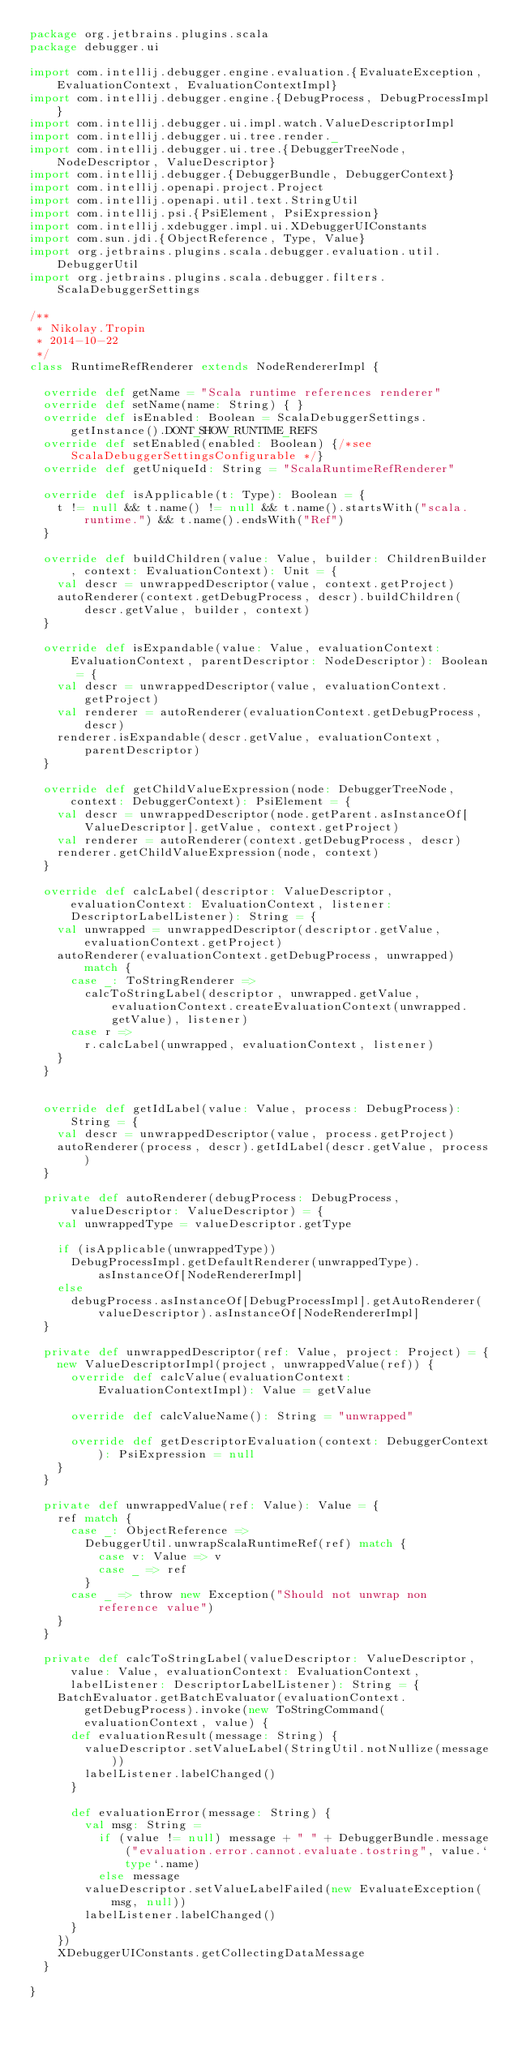<code> <loc_0><loc_0><loc_500><loc_500><_Scala_>package org.jetbrains.plugins.scala
package debugger.ui

import com.intellij.debugger.engine.evaluation.{EvaluateException, EvaluationContext, EvaluationContextImpl}
import com.intellij.debugger.engine.{DebugProcess, DebugProcessImpl}
import com.intellij.debugger.ui.impl.watch.ValueDescriptorImpl
import com.intellij.debugger.ui.tree.render._
import com.intellij.debugger.ui.tree.{DebuggerTreeNode, NodeDescriptor, ValueDescriptor}
import com.intellij.debugger.{DebuggerBundle, DebuggerContext}
import com.intellij.openapi.project.Project
import com.intellij.openapi.util.text.StringUtil
import com.intellij.psi.{PsiElement, PsiExpression}
import com.intellij.xdebugger.impl.ui.XDebuggerUIConstants
import com.sun.jdi.{ObjectReference, Type, Value}
import org.jetbrains.plugins.scala.debugger.evaluation.util.DebuggerUtil
import org.jetbrains.plugins.scala.debugger.filters.ScalaDebuggerSettings

/**
 * Nikolay.Tropin
 * 2014-10-22
 */
class RuntimeRefRenderer extends NodeRendererImpl {

  override def getName = "Scala runtime references renderer"
  override def setName(name: String) { }
  override def isEnabled: Boolean = ScalaDebuggerSettings.getInstance().DONT_SHOW_RUNTIME_REFS
  override def setEnabled(enabled: Boolean) {/*see ScalaDebuggerSettingsConfigurable */}
  override def getUniqueId: String = "ScalaRuntimeRefRenderer"

  override def isApplicable(t: Type): Boolean = {
    t != null && t.name() != null && t.name().startsWith("scala.runtime.") && t.name().endsWith("Ref")
  }
  
  override def buildChildren(value: Value, builder: ChildrenBuilder, context: EvaluationContext): Unit = {
    val descr = unwrappedDescriptor(value, context.getProject)
    autoRenderer(context.getDebugProcess, descr).buildChildren(descr.getValue, builder, context)
  }

  override def isExpandable(value: Value, evaluationContext: EvaluationContext, parentDescriptor: NodeDescriptor): Boolean = {
    val descr = unwrappedDescriptor(value, evaluationContext.getProject)
    val renderer = autoRenderer(evaluationContext.getDebugProcess, descr)
    renderer.isExpandable(descr.getValue, evaluationContext, parentDescriptor)
  }

  override def getChildValueExpression(node: DebuggerTreeNode, context: DebuggerContext): PsiElement = {
    val descr = unwrappedDescriptor(node.getParent.asInstanceOf[ValueDescriptor].getValue, context.getProject)
    val renderer = autoRenderer(context.getDebugProcess, descr)
    renderer.getChildValueExpression(node, context)
  }

  override def calcLabel(descriptor: ValueDescriptor, evaluationContext: EvaluationContext, listener: DescriptorLabelListener): String = {
    val unwrapped = unwrappedDescriptor(descriptor.getValue, evaluationContext.getProject)
    autoRenderer(evaluationContext.getDebugProcess, unwrapped) match {
      case _: ToStringRenderer =>
        calcToStringLabel(descriptor, unwrapped.getValue, evaluationContext.createEvaluationContext(unwrapped.getValue), listener)
      case r =>
        r.calcLabel(unwrapped, evaluationContext, listener)
    }
  }


  override def getIdLabel(value: Value, process: DebugProcess): String = {
    val descr = unwrappedDescriptor(value, process.getProject)
    autoRenderer(process, descr).getIdLabel(descr.getValue, process)
  }

  private def autoRenderer(debugProcess: DebugProcess, valueDescriptor: ValueDescriptor) = {
    val unwrappedType = valueDescriptor.getType

    if (isApplicable(unwrappedType))
      DebugProcessImpl.getDefaultRenderer(unwrappedType).asInstanceOf[NodeRendererImpl]
    else
      debugProcess.asInstanceOf[DebugProcessImpl].getAutoRenderer(valueDescriptor).asInstanceOf[NodeRendererImpl]
  }
  
  private def unwrappedDescriptor(ref: Value, project: Project) = {
    new ValueDescriptorImpl(project, unwrappedValue(ref)) {
      override def calcValue(evaluationContext: EvaluationContextImpl): Value = getValue

      override def calcValueName(): String = "unwrapped"

      override def getDescriptorEvaluation(context: DebuggerContext): PsiExpression = null
    }
  }

  private def unwrappedValue(ref: Value): Value = {
    ref match {
      case _: ObjectReference =>
        DebuggerUtil.unwrapScalaRuntimeRef(ref) match {
          case v: Value => v
          case _ => ref
        }
      case _ => throw new Exception("Should not unwrap non reference value")
    }
  }

  private def calcToStringLabel(valueDescriptor: ValueDescriptor, value: Value, evaluationContext: EvaluationContext, labelListener: DescriptorLabelListener): String = {
    BatchEvaluator.getBatchEvaluator(evaluationContext.getDebugProcess).invoke(new ToStringCommand(evaluationContext, value) {
      def evaluationResult(message: String) {
        valueDescriptor.setValueLabel(StringUtil.notNullize(message))
        labelListener.labelChanged()
      }

      def evaluationError(message: String) {
        val msg: String =
          if (value != null) message + " " + DebuggerBundle.message("evaluation.error.cannot.evaluate.tostring", value.`type`.name)
          else message
        valueDescriptor.setValueLabelFailed(new EvaluateException(msg, null))
        labelListener.labelChanged()
      }
    })
    XDebuggerUIConstants.getCollectingDataMessage
  }

}
</code> 